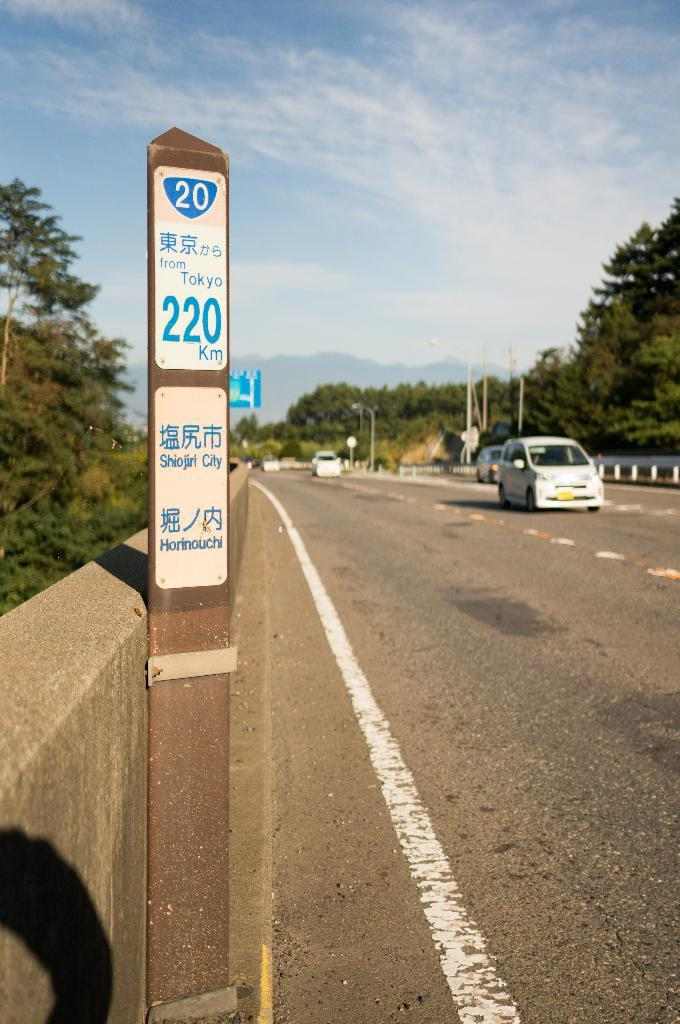<image>
Provide a brief description of the given image. A post has a sign that reads "from Tokyo 220 km" 